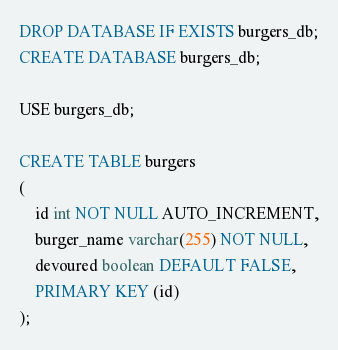Convert code to text. <code><loc_0><loc_0><loc_500><loc_500><_SQL_>DROP DATABASE IF EXISTS burgers_db;
CREATE DATABASE burgers_db;

USE burgers_db;

CREATE TABLE burgers
(
	id int NOT NULL AUTO_INCREMENT,
	burger_name varchar(255) NOT NULL,
    devoured boolean DEFAULT FALSE,
	PRIMARY KEY (id)
);</code> 